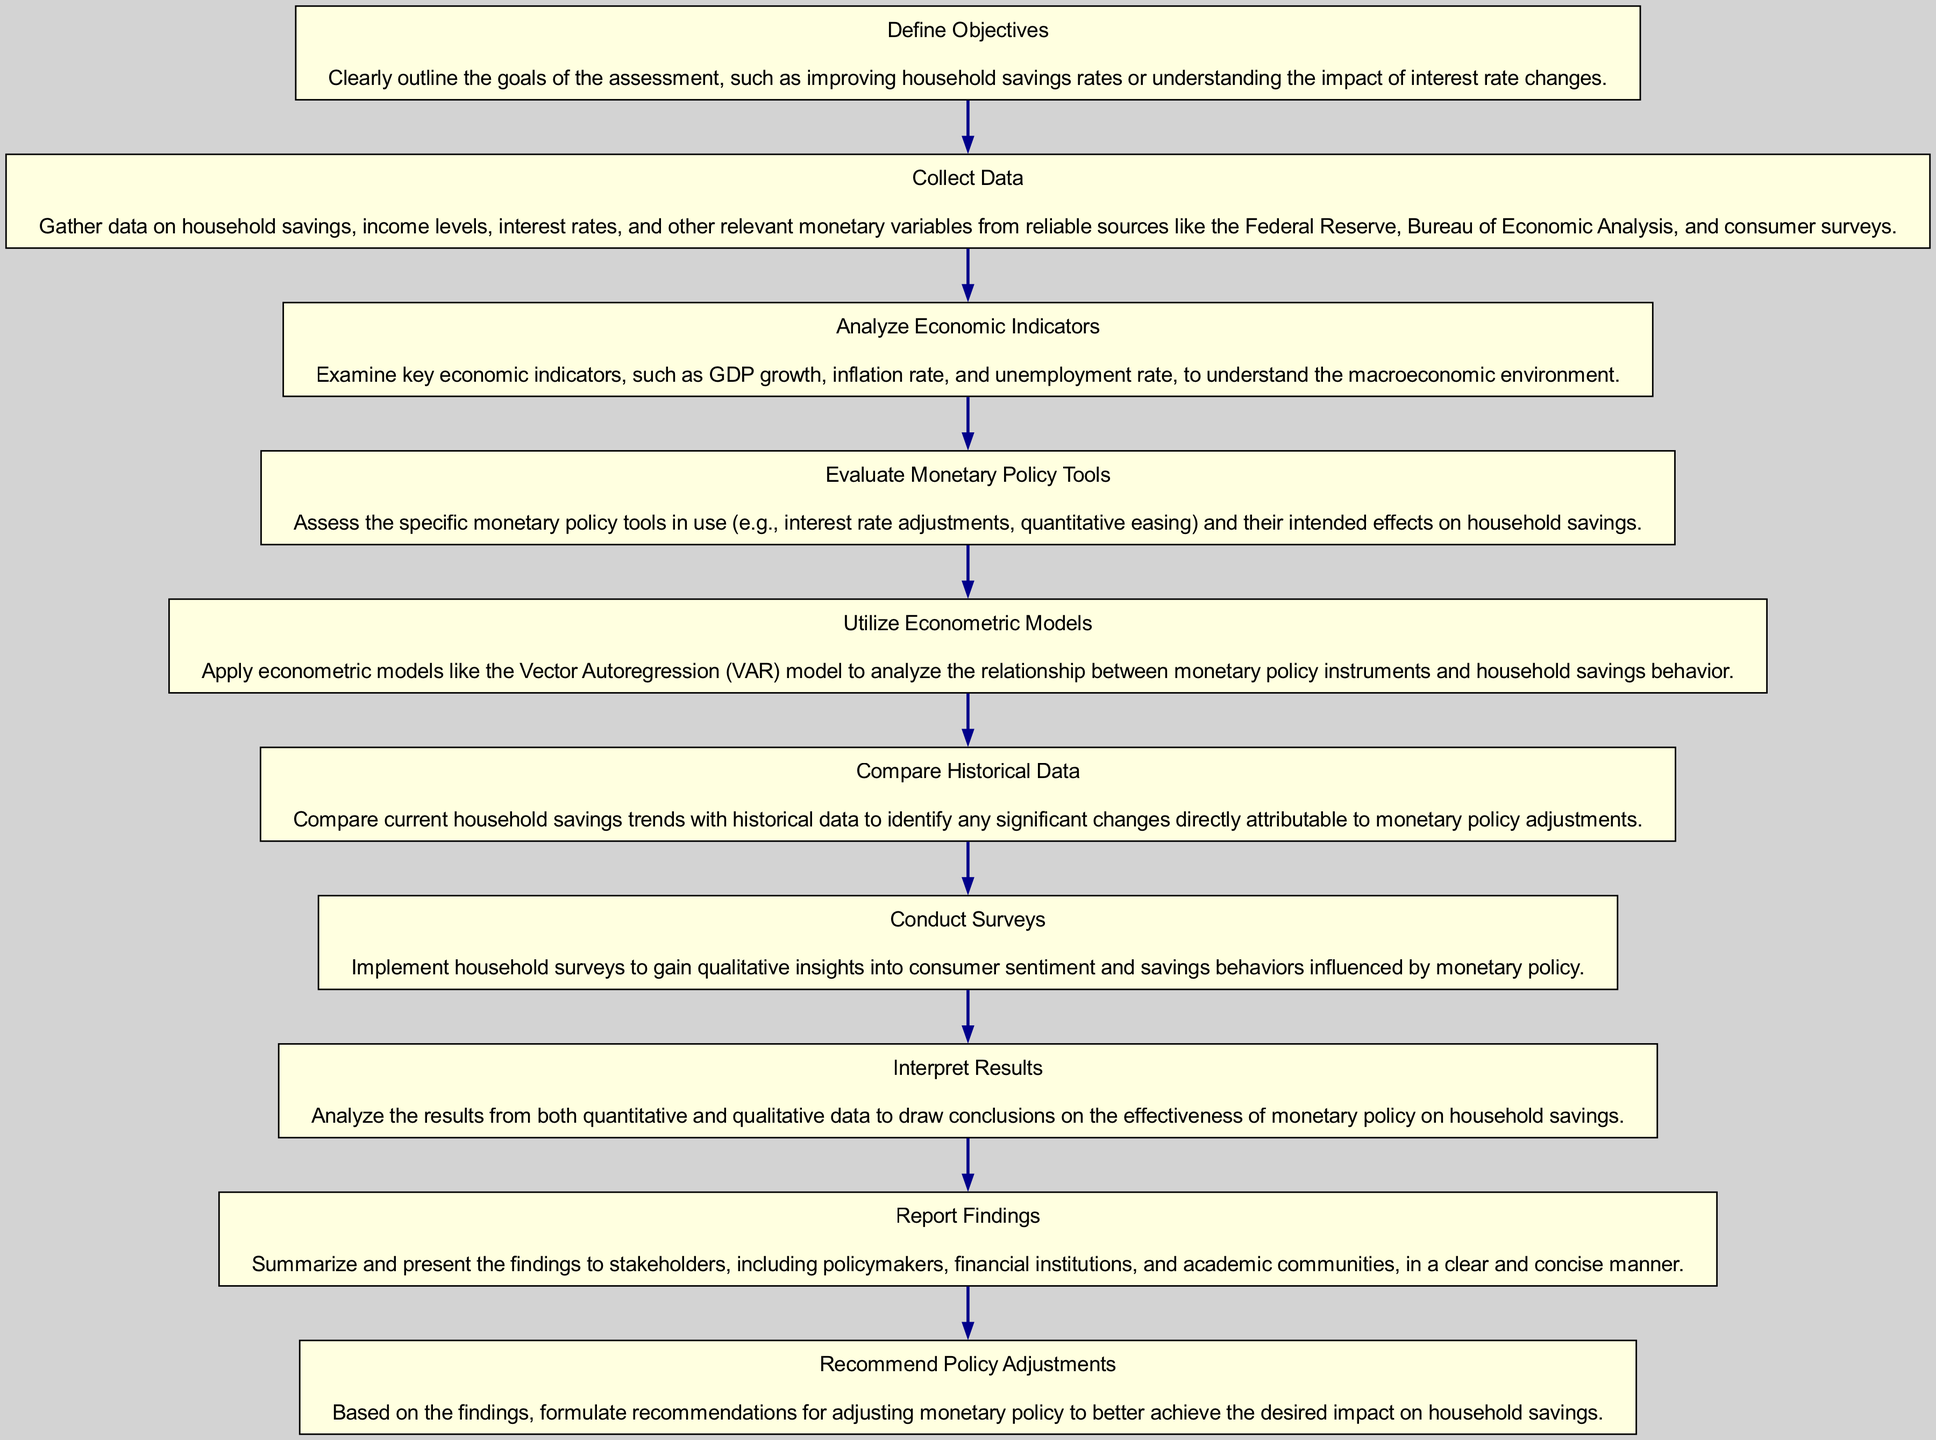What is the first step in assessing monetary policy's effectiveness? The first step is to "Define Objectives." This is identified as the starting node in the flow chart, showing it's the first action taken in the process.
Answer: Define Objectives How many steps are there in total? By counting all the nodes in the flow chart, it is apparent that there are ten distinct steps outlined in the process.
Answer: 10 Which step involves the evaluation of specific monetary policy tools? The step that involves assessing monetary policy tools is "Evaluate Monetary Policy Tools." It's a specific node within the flow that focuses on the tools themselves.
Answer: Evaluate Monetary Policy Tools What action follows the collection of data? The next action after data collection is "Analyze Economic Indicators." This relationship is indicated by the directional edge connecting these two nodes in the flow.
Answer: Analyze Economic Indicators What kind of models are suggested for use in the analysis? The diagram mentions using "Econometric Models," specifically citing the Vector Autoregression (VAR) model. This is part of a particular step that deals with applying models to examine behavior.
Answer: Econometric Models Which two steps involve gathering insights on consumer behavior? The steps that gather insights on consumer behavior are "Conduct Surveys" and "Interpret Results." These steps focus on qualitative and quantitative aspects of understanding consumer behavior influenced by monetary policy.
Answer: Conduct Surveys and Interpret Results In what step does the comparison of current and historical data take place? The comparison happens in the "Compare Historical Data" step. The flow indicates that this analysis follows after the previous assessments to draw insights.
Answer: Compare Historical Data What is the final step in the assessment process? The last step outlined in the flow chart is "Recommend Policy Adjustments," signaling the conclusion of the assessment with actionable recommendations.
Answer: Recommend Policy Adjustments How many steps entail data analysis activities? There are four steps related to data analysis activities, which are "Collect Data," "Analyze Economic Indicators," "Utilize Econometric Models," and "Compare Historical Data." These steps focus on different forms of data analysis leading to interpretations.
Answer: 4 